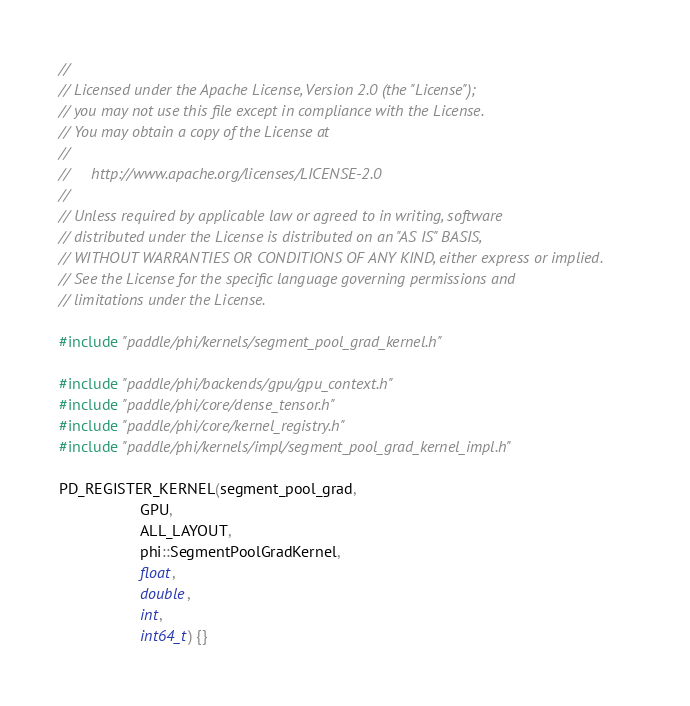Convert code to text. <code><loc_0><loc_0><loc_500><loc_500><_Cuda_>//
// Licensed under the Apache License, Version 2.0 (the "License");
// you may not use this file except in compliance with the License.
// You may obtain a copy of the License at
//
//     http://www.apache.org/licenses/LICENSE-2.0
//
// Unless required by applicable law or agreed to in writing, software
// distributed under the License is distributed on an "AS IS" BASIS,
// WITHOUT WARRANTIES OR CONDITIONS OF ANY KIND, either express or implied.
// See the License for the specific language governing permissions and
// limitations under the License.

#include "paddle/phi/kernels/segment_pool_grad_kernel.h"

#include "paddle/phi/backends/gpu/gpu_context.h"
#include "paddle/phi/core/dense_tensor.h"
#include "paddle/phi/core/kernel_registry.h"
#include "paddle/phi/kernels/impl/segment_pool_grad_kernel_impl.h"

PD_REGISTER_KERNEL(segment_pool_grad,
                   GPU,
                   ALL_LAYOUT,
                   phi::SegmentPoolGradKernel,
                   float,
                   double,
                   int,
                   int64_t) {}
</code> 